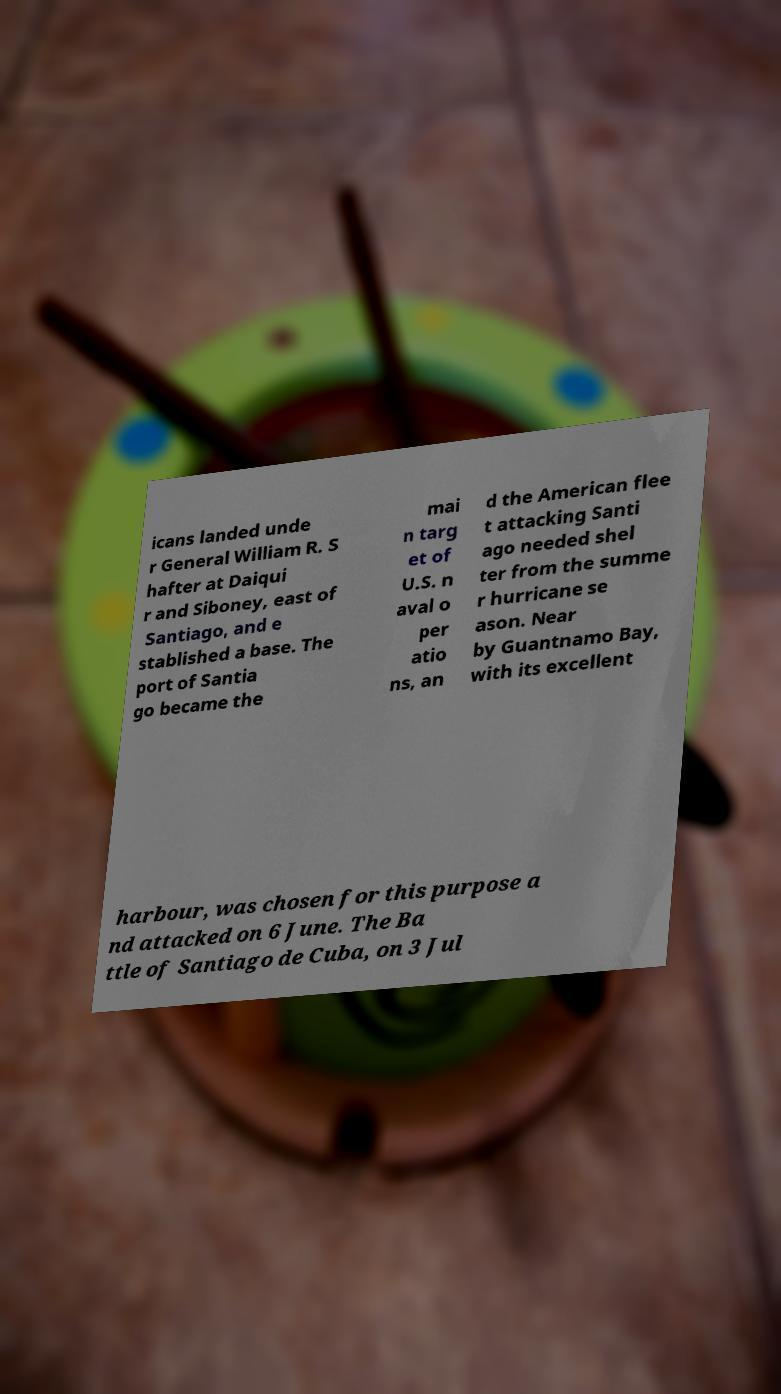Could you extract and type out the text from this image? icans landed unde r General William R. S hafter at Daiqui r and Siboney, east of Santiago, and e stablished a base. The port of Santia go became the mai n targ et of U.S. n aval o per atio ns, an d the American flee t attacking Santi ago needed shel ter from the summe r hurricane se ason. Near by Guantnamo Bay, with its excellent harbour, was chosen for this purpose a nd attacked on 6 June. The Ba ttle of Santiago de Cuba, on 3 Jul 